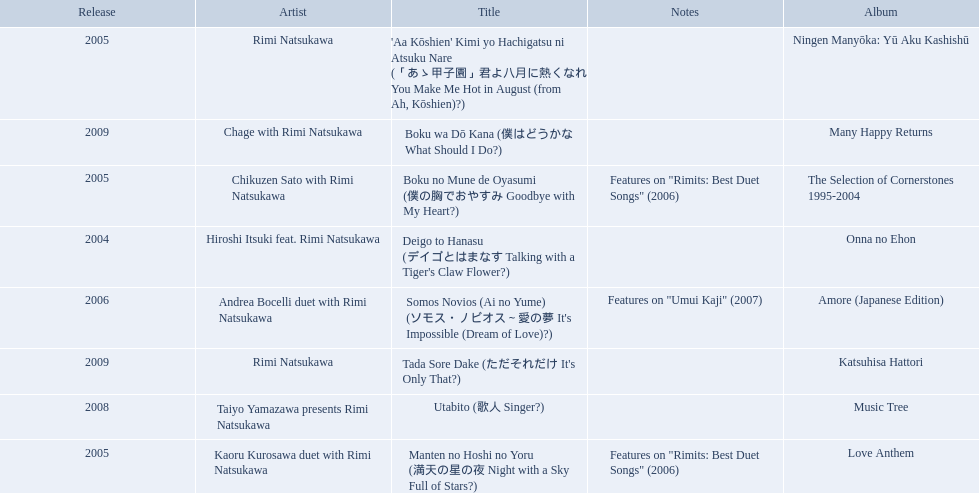What are the notes for sky full of stars? Features on "Rimits: Best Duet Songs" (2006). What other song features this same note? Boku no Mune de Oyasumi (僕の胸でおやすみ Goodbye with My Heart?). 